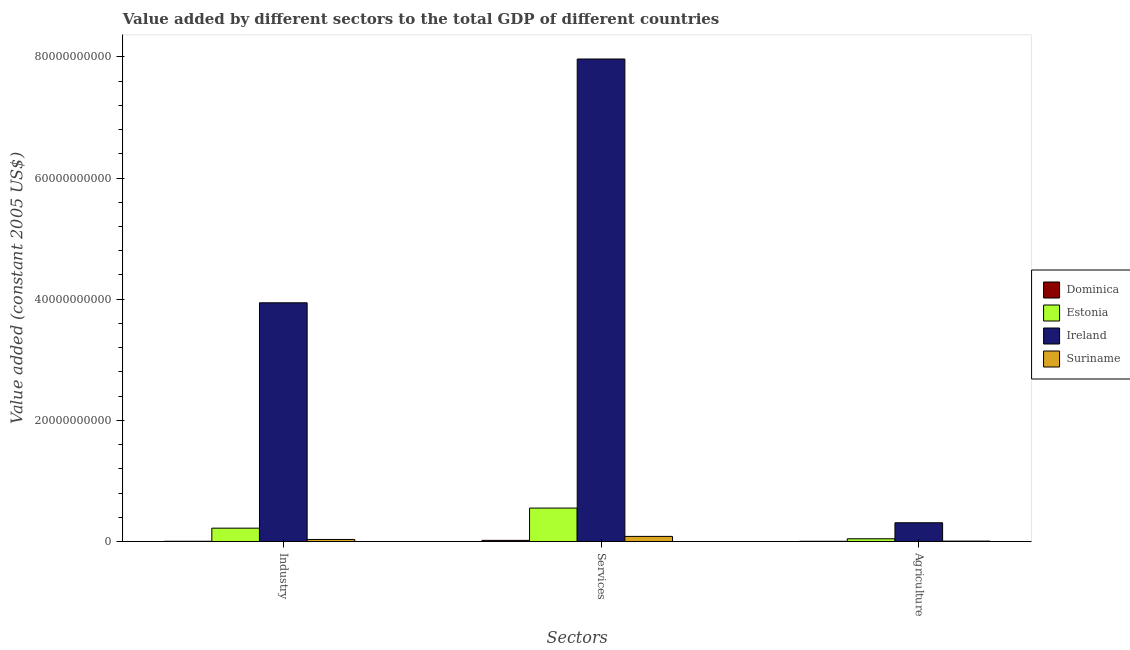Are the number of bars per tick equal to the number of legend labels?
Offer a very short reply. Yes. How many bars are there on the 3rd tick from the right?
Make the answer very short. 4. What is the label of the 2nd group of bars from the left?
Keep it short and to the point. Services. What is the value added by industrial sector in Suriname?
Provide a short and direct response. 3.47e+08. Across all countries, what is the maximum value added by agricultural sector?
Provide a short and direct response. 3.10e+09. Across all countries, what is the minimum value added by agricultural sector?
Ensure brevity in your answer.  4.65e+07. In which country was the value added by industrial sector maximum?
Offer a very short reply. Ireland. In which country was the value added by industrial sector minimum?
Your answer should be compact. Dominica. What is the total value added by agricultural sector in the graph?
Ensure brevity in your answer.  3.68e+09. What is the difference between the value added by agricultural sector in Dominica and that in Suriname?
Give a very brief answer. -2.84e+07. What is the difference between the value added by agricultural sector in Dominica and the value added by industrial sector in Estonia?
Offer a terse response. -2.16e+09. What is the average value added by agricultural sector per country?
Your response must be concise. 9.21e+08. What is the difference between the value added by services and value added by industrial sector in Suriname?
Make the answer very short. 5.06e+08. What is the ratio of the value added by services in Suriname to that in Dominica?
Keep it short and to the point. 4.34. Is the value added by industrial sector in Ireland less than that in Estonia?
Offer a very short reply. No. What is the difference between the highest and the second highest value added by agricultural sector?
Keep it short and to the point. 2.64e+09. What is the difference between the highest and the lowest value added by industrial sector?
Keep it short and to the point. 3.94e+1. In how many countries, is the value added by services greater than the average value added by services taken over all countries?
Make the answer very short. 1. What does the 2nd bar from the left in Industry represents?
Your response must be concise. Estonia. What does the 4th bar from the right in Agriculture represents?
Your response must be concise. Dominica. Is it the case that in every country, the sum of the value added by industrial sector and value added by services is greater than the value added by agricultural sector?
Your answer should be compact. Yes. How many countries are there in the graph?
Offer a very short reply. 4. Are the values on the major ticks of Y-axis written in scientific E-notation?
Ensure brevity in your answer.  No. Does the graph contain grids?
Provide a short and direct response. No. What is the title of the graph?
Keep it short and to the point. Value added by different sectors to the total GDP of different countries. Does "Bulgaria" appear as one of the legend labels in the graph?
Offer a terse response. No. What is the label or title of the X-axis?
Give a very brief answer. Sectors. What is the label or title of the Y-axis?
Give a very brief answer. Value added (constant 2005 US$). What is the Value added (constant 2005 US$) in Dominica in Industry?
Provide a short and direct response. 5.05e+07. What is the Value added (constant 2005 US$) in Estonia in Industry?
Provide a short and direct response. 2.21e+09. What is the Value added (constant 2005 US$) of Ireland in Industry?
Offer a terse response. 3.94e+1. What is the Value added (constant 2005 US$) in Suriname in Industry?
Offer a very short reply. 3.47e+08. What is the Value added (constant 2005 US$) of Dominica in Services?
Your answer should be compact. 1.96e+08. What is the Value added (constant 2005 US$) of Estonia in Services?
Your answer should be very brief. 5.52e+09. What is the Value added (constant 2005 US$) of Ireland in Services?
Provide a succinct answer. 7.96e+1. What is the Value added (constant 2005 US$) of Suriname in Services?
Provide a succinct answer. 8.53e+08. What is the Value added (constant 2005 US$) of Dominica in Agriculture?
Make the answer very short. 4.65e+07. What is the Value added (constant 2005 US$) of Estonia in Agriculture?
Provide a succinct answer. 4.59e+08. What is the Value added (constant 2005 US$) of Ireland in Agriculture?
Provide a short and direct response. 3.10e+09. What is the Value added (constant 2005 US$) of Suriname in Agriculture?
Provide a succinct answer. 7.49e+07. Across all Sectors, what is the maximum Value added (constant 2005 US$) of Dominica?
Ensure brevity in your answer.  1.96e+08. Across all Sectors, what is the maximum Value added (constant 2005 US$) in Estonia?
Keep it short and to the point. 5.52e+09. Across all Sectors, what is the maximum Value added (constant 2005 US$) of Ireland?
Offer a terse response. 7.96e+1. Across all Sectors, what is the maximum Value added (constant 2005 US$) in Suriname?
Make the answer very short. 8.53e+08. Across all Sectors, what is the minimum Value added (constant 2005 US$) of Dominica?
Provide a short and direct response. 4.65e+07. Across all Sectors, what is the minimum Value added (constant 2005 US$) of Estonia?
Provide a succinct answer. 4.59e+08. Across all Sectors, what is the minimum Value added (constant 2005 US$) in Ireland?
Your answer should be very brief. 3.10e+09. Across all Sectors, what is the minimum Value added (constant 2005 US$) in Suriname?
Make the answer very short. 7.49e+07. What is the total Value added (constant 2005 US$) of Dominica in the graph?
Offer a very short reply. 2.94e+08. What is the total Value added (constant 2005 US$) of Estonia in the graph?
Offer a very short reply. 8.19e+09. What is the total Value added (constant 2005 US$) in Ireland in the graph?
Make the answer very short. 1.22e+11. What is the total Value added (constant 2005 US$) of Suriname in the graph?
Ensure brevity in your answer.  1.28e+09. What is the difference between the Value added (constant 2005 US$) of Dominica in Industry and that in Services?
Keep it short and to the point. -1.46e+08. What is the difference between the Value added (constant 2005 US$) in Estonia in Industry and that in Services?
Give a very brief answer. -3.31e+09. What is the difference between the Value added (constant 2005 US$) of Ireland in Industry and that in Services?
Give a very brief answer. -4.02e+1. What is the difference between the Value added (constant 2005 US$) of Suriname in Industry and that in Services?
Your answer should be compact. -5.06e+08. What is the difference between the Value added (constant 2005 US$) of Dominica in Industry and that in Agriculture?
Your response must be concise. 4.02e+06. What is the difference between the Value added (constant 2005 US$) in Estonia in Industry and that in Agriculture?
Your answer should be very brief. 1.75e+09. What is the difference between the Value added (constant 2005 US$) of Ireland in Industry and that in Agriculture?
Provide a succinct answer. 3.63e+1. What is the difference between the Value added (constant 2005 US$) in Suriname in Industry and that in Agriculture?
Ensure brevity in your answer.  2.72e+08. What is the difference between the Value added (constant 2005 US$) of Dominica in Services and that in Agriculture?
Your answer should be compact. 1.50e+08. What is the difference between the Value added (constant 2005 US$) in Estonia in Services and that in Agriculture?
Make the answer very short. 5.07e+09. What is the difference between the Value added (constant 2005 US$) in Ireland in Services and that in Agriculture?
Provide a short and direct response. 7.65e+1. What is the difference between the Value added (constant 2005 US$) in Suriname in Services and that in Agriculture?
Offer a very short reply. 7.78e+08. What is the difference between the Value added (constant 2005 US$) in Dominica in Industry and the Value added (constant 2005 US$) in Estonia in Services?
Your answer should be compact. -5.47e+09. What is the difference between the Value added (constant 2005 US$) in Dominica in Industry and the Value added (constant 2005 US$) in Ireland in Services?
Your response must be concise. -7.96e+1. What is the difference between the Value added (constant 2005 US$) of Dominica in Industry and the Value added (constant 2005 US$) of Suriname in Services?
Your answer should be compact. -8.03e+08. What is the difference between the Value added (constant 2005 US$) of Estonia in Industry and the Value added (constant 2005 US$) of Ireland in Services?
Ensure brevity in your answer.  -7.74e+1. What is the difference between the Value added (constant 2005 US$) of Estonia in Industry and the Value added (constant 2005 US$) of Suriname in Services?
Give a very brief answer. 1.36e+09. What is the difference between the Value added (constant 2005 US$) of Ireland in Industry and the Value added (constant 2005 US$) of Suriname in Services?
Provide a short and direct response. 3.86e+1. What is the difference between the Value added (constant 2005 US$) of Dominica in Industry and the Value added (constant 2005 US$) of Estonia in Agriculture?
Provide a short and direct response. -4.08e+08. What is the difference between the Value added (constant 2005 US$) of Dominica in Industry and the Value added (constant 2005 US$) of Ireland in Agriculture?
Give a very brief answer. -3.05e+09. What is the difference between the Value added (constant 2005 US$) of Dominica in Industry and the Value added (constant 2005 US$) of Suriname in Agriculture?
Keep it short and to the point. -2.44e+07. What is the difference between the Value added (constant 2005 US$) of Estonia in Industry and the Value added (constant 2005 US$) of Ireland in Agriculture?
Keep it short and to the point. -8.92e+08. What is the difference between the Value added (constant 2005 US$) in Estonia in Industry and the Value added (constant 2005 US$) in Suriname in Agriculture?
Your answer should be compact. 2.14e+09. What is the difference between the Value added (constant 2005 US$) in Ireland in Industry and the Value added (constant 2005 US$) in Suriname in Agriculture?
Offer a terse response. 3.93e+1. What is the difference between the Value added (constant 2005 US$) in Dominica in Services and the Value added (constant 2005 US$) in Estonia in Agriculture?
Provide a succinct answer. -2.62e+08. What is the difference between the Value added (constant 2005 US$) of Dominica in Services and the Value added (constant 2005 US$) of Ireland in Agriculture?
Your answer should be compact. -2.91e+09. What is the difference between the Value added (constant 2005 US$) of Dominica in Services and the Value added (constant 2005 US$) of Suriname in Agriculture?
Make the answer very short. 1.22e+08. What is the difference between the Value added (constant 2005 US$) in Estonia in Services and the Value added (constant 2005 US$) in Ireland in Agriculture?
Your response must be concise. 2.42e+09. What is the difference between the Value added (constant 2005 US$) in Estonia in Services and the Value added (constant 2005 US$) in Suriname in Agriculture?
Keep it short and to the point. 5.45e+09. What is the difference between the Value added (constant 2005 US$) of Ireland in Services and the Value added (constant 2005 US$) of Suriname in Agriculture?
Provide a short and direct response. 7.96e+1. What is the average Value added (constant 2005 US$) of Dominica per Sectors?
Your answer should be compact. 9.78e+07. What is the average Value added (constant 2005 US$) of Estonia per Sectors?
Offer a very short reply. 2.73e+09. What is the average Value added (constant 2005 US$) in Ireland per Sectors?
Your answer should be compact. 4.07e+1. What is the average Value added (constant 2005 US$) of Suriname per Sectors?
Your answer should be compact. 4.25e+08. What is the difference between the Value added (constant 2005 US$) of Dominica and Value added (constant 2005 US$) of Estonia in Industry?
Provide a succinct answer. -2.16e+09. What is the difference between the Value added (constant 2005 US$) of Dominica and Value added (constant 2005 US$) of Ireland in Industry?
Keep it short and to the point. -3.94e+1. What is the difference between the Value added (constant 2005 US$) in Dominica and Value added (constant 2005 US$) in Suriname in Industry?
Give a very brief answer. -2.97e+08. What is the difference between the Value added (constant 2005 US$) of Estonia and Value added (constant 2005 US$) of Ireland in Industry?
Provide a succinct answer. -3.72e+1. What is the difference between the Value added (constant 2005 US$) of Estonia and Value added (constant 2005 US$) of Suriname in Industry?
Offer a terse response. 1.86e+09. What is the difference between the Value added (constant 2005 US$) in Ireland and Value added (constant 2005 US$) in Suriname in Industry?
Offer a very short reply. 3.91e+1. What is the difference between the Value added (constant 2005 US$) of Dominica and Value added (constant 2005 US$) of Estonia in Services?
Give a very brief answer. -5.33e+09. What is the difference between the Value added (constant 2005 US$) of Dominica and Value added (constant 2005 US$) of Ireland in Services?
Your answer should be very brief. -7.94e+1. What is the difference between the Value added (constant 2005 US$) in Dominica and Value added (constant 2005 US$) in Suriname in Services?
Make the answer very short. -6.57e+08. What is the difference between the Value added (constant 2005 US$) in Estonia and Value added (constant 2005 US$) in Ireland in Services?
Your answer should be very brief. -7.41e+1. What is the difference between the Value added (constant 2005 US$) in Estonia and Value added (constant 2005 US$) in Suriname in Services?
Ensure brevity in your answer.  4.67e+09. What is the difference between the Value added (constant 2005 US$) of Ireland and Value added (constant 2005 US$) of Suriname in Services?
Give a very brief answer. 7.88e+1. What is the difference between the Value added (constant 2005 US$) of Dominica and Value added (constant 2005 US$) of Estonia in Agriculture?
Provide a succinct answer. -4.12e+08. What is the difference between the Value added (constant 2005 US$) in Dominica and Value added (constant 2005 US$) in Ireland in Agriculture?
Keep it short and to the point. -3.06e+09. What is the difference between the Value added (constant 2005 US$) in Dominica and Value added (constant 2005 US$) in Suriname in Agriculture?
Your answer should be compact. -2.84e+07. What is the difference between the Value added (constant 2005 US$) of Estonia and Value added (constant 2005 US$) of Ireland in Agriculture?
Your response must be concise. -2.64e+09. What is the difference between the Value added (constant 2005 US$) in Estonia and Value added (constant 2005 US$) in Suriname in Agriculture?
Offer a very short reply. 3.84e+08. What is the difference between the Value added (constant 2005 US$) in Ireland and Value added (constant 2005 US$) in Suriname in Agriculture?
Provide a succinct answer. 3.03e+09. What is the ratio of the Value added (constant 2005 US$) in Dominica in Industry to that in Services?
Offer a terse response. 0.26. What is the ratio of the Value added (constant 2005 US$) of Estonia in Industry to that in Services?
Provide a short and direct response. 0.4. What is the ratio of the Value added (constant 2005 US$) of Ireland in Industry to that in Services?
Provide a short and direct response. 0.49. What is the ratio of the Value added (constant 2005 US$) in Suriname in Industry to that in Services?
Provide a succinct answer. 0.41. What is the ratio of the Value added (constant 2005 US$) of Dominica in Industry to that in Agriculture?
Your answer should be compact. 1.09. What is the ratio of the Value added (constant 2005 US$) in Estonia in Industry to that in Agriculture?
Offer a terse response. 4.82. What is the ratio of the Value added (constant 2005 US$) of Ireland in Industry to that in Agriculture?
Offer a terse response. 12.7. What is the ratio of the Value added (constant 2005 US$) in Suriname in Industry to that in Agriculture?
Your answer should be compact. 4.63. What is the ratio of the Value added (constant 2005 US$) of Dominica in Services to that in Agriculture?
Your answer should be very brief. 4.22. What is the ratio of the Value added (constant 2005 US$) of Estonia in Services to that in Agriculture?
Provide a short and direct response. 12.04. What is the ratio of the Value added (constant 2005 US$) of Ireland in Services to that in Agriculture?
Offer a terse response. 25.66. What is the ratio of the Value added (constant 2005 US$) of Suriname in Services to that in Agriculture?
Your answer should be compact. 11.39. What is the difference between the highest and the second highest Value added (constant 2005 US$) of Dominica?
Your answer should be compact. 1.46e+08. What is the difference between the highest and the second highest Value added (constant 2005 US$) in Estonia?
Keep it short and to the point. 3.31e+09. What is the difference between the highest and the second highest Value added (constant 2005 US$) in Ireland?
Ensure brevity in your answer.  4.02e+1. What is the difference between the highest and the second highest Value added (constant 2005 US$) in Suriname?
Give a very brief answer. 5.06e+08. What is the difference between the highest and the lowest Value added (constant 2005 US$) in Dominica?
Make the answer very short. 1.50e+08. What is the difference between the highest and the lowest Value added (constant 2005 US$) of Estonia?
Offer a terse response. 5.07e+09. What is the difference between the highest and the lowest Value added (constant 2005 US$) of Ireland?
Make the answer very short. 7.65e+1. What is the difference between the highest and the lowest Value added (constant 2005 US$) in Suriname?
Give a very brief answer. 7.78e+08. 